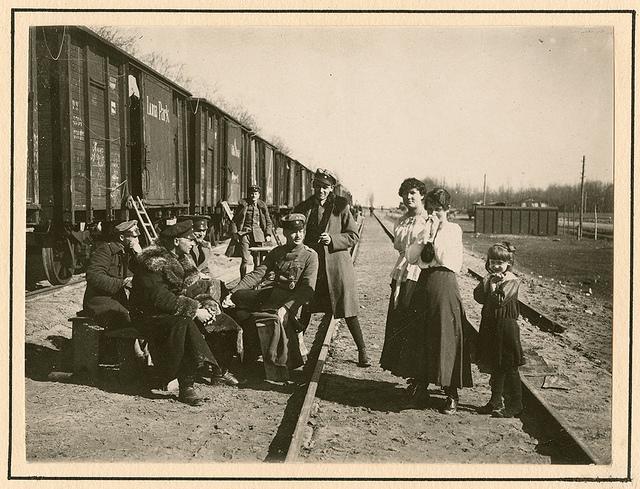Is this woman skiing?
Quick response, please. No. Is this photo in color?
Give a very brief answer. No. Are they fighting?
Quick response, please. No. How many females are there?
Quick response, please. 3. 